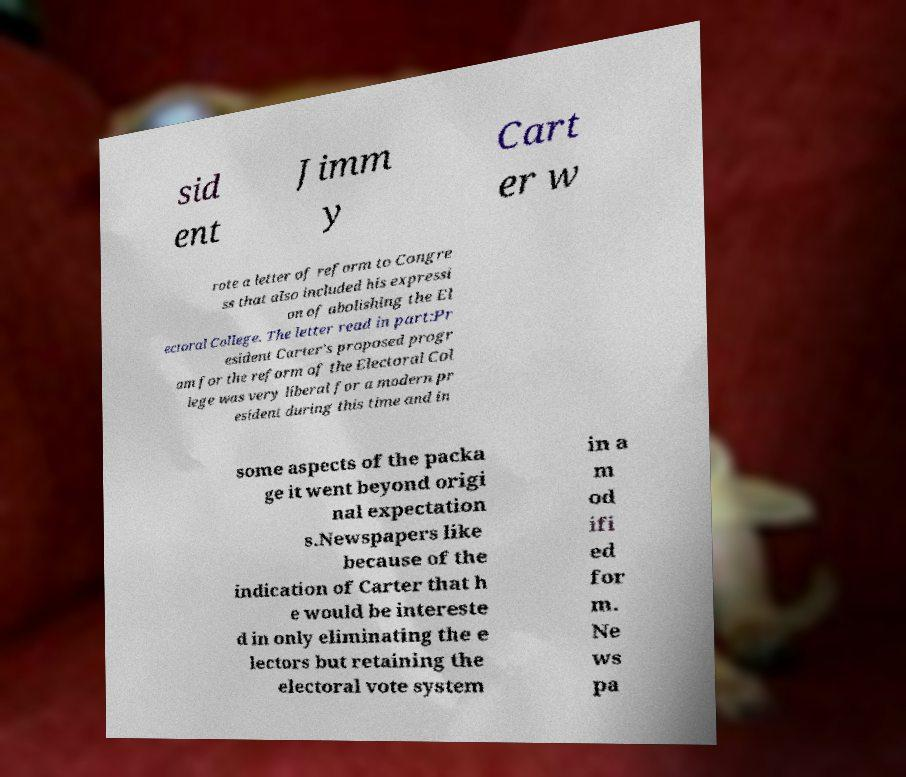What messages or text are displayed in this image? I need them in a readable, typed format. sid ent Jimm y Cart er w rote a letter of reform to Congre ss that also included his expressi on of abolishing the El ectoral College. The letter read in part:Pr esident Carter's proposed progr am for the reform of the Electoral Col lege was very liberal for a modern pr esident during this time and in some aspects of the packa ge it went beyond origi nal expectation s.Newspapers like because of the indication of Carter that h e would be intereste d in only eliminating the e lectors but retaining the electoral vote system in a m od ifi ed for m. Ne ws pa 